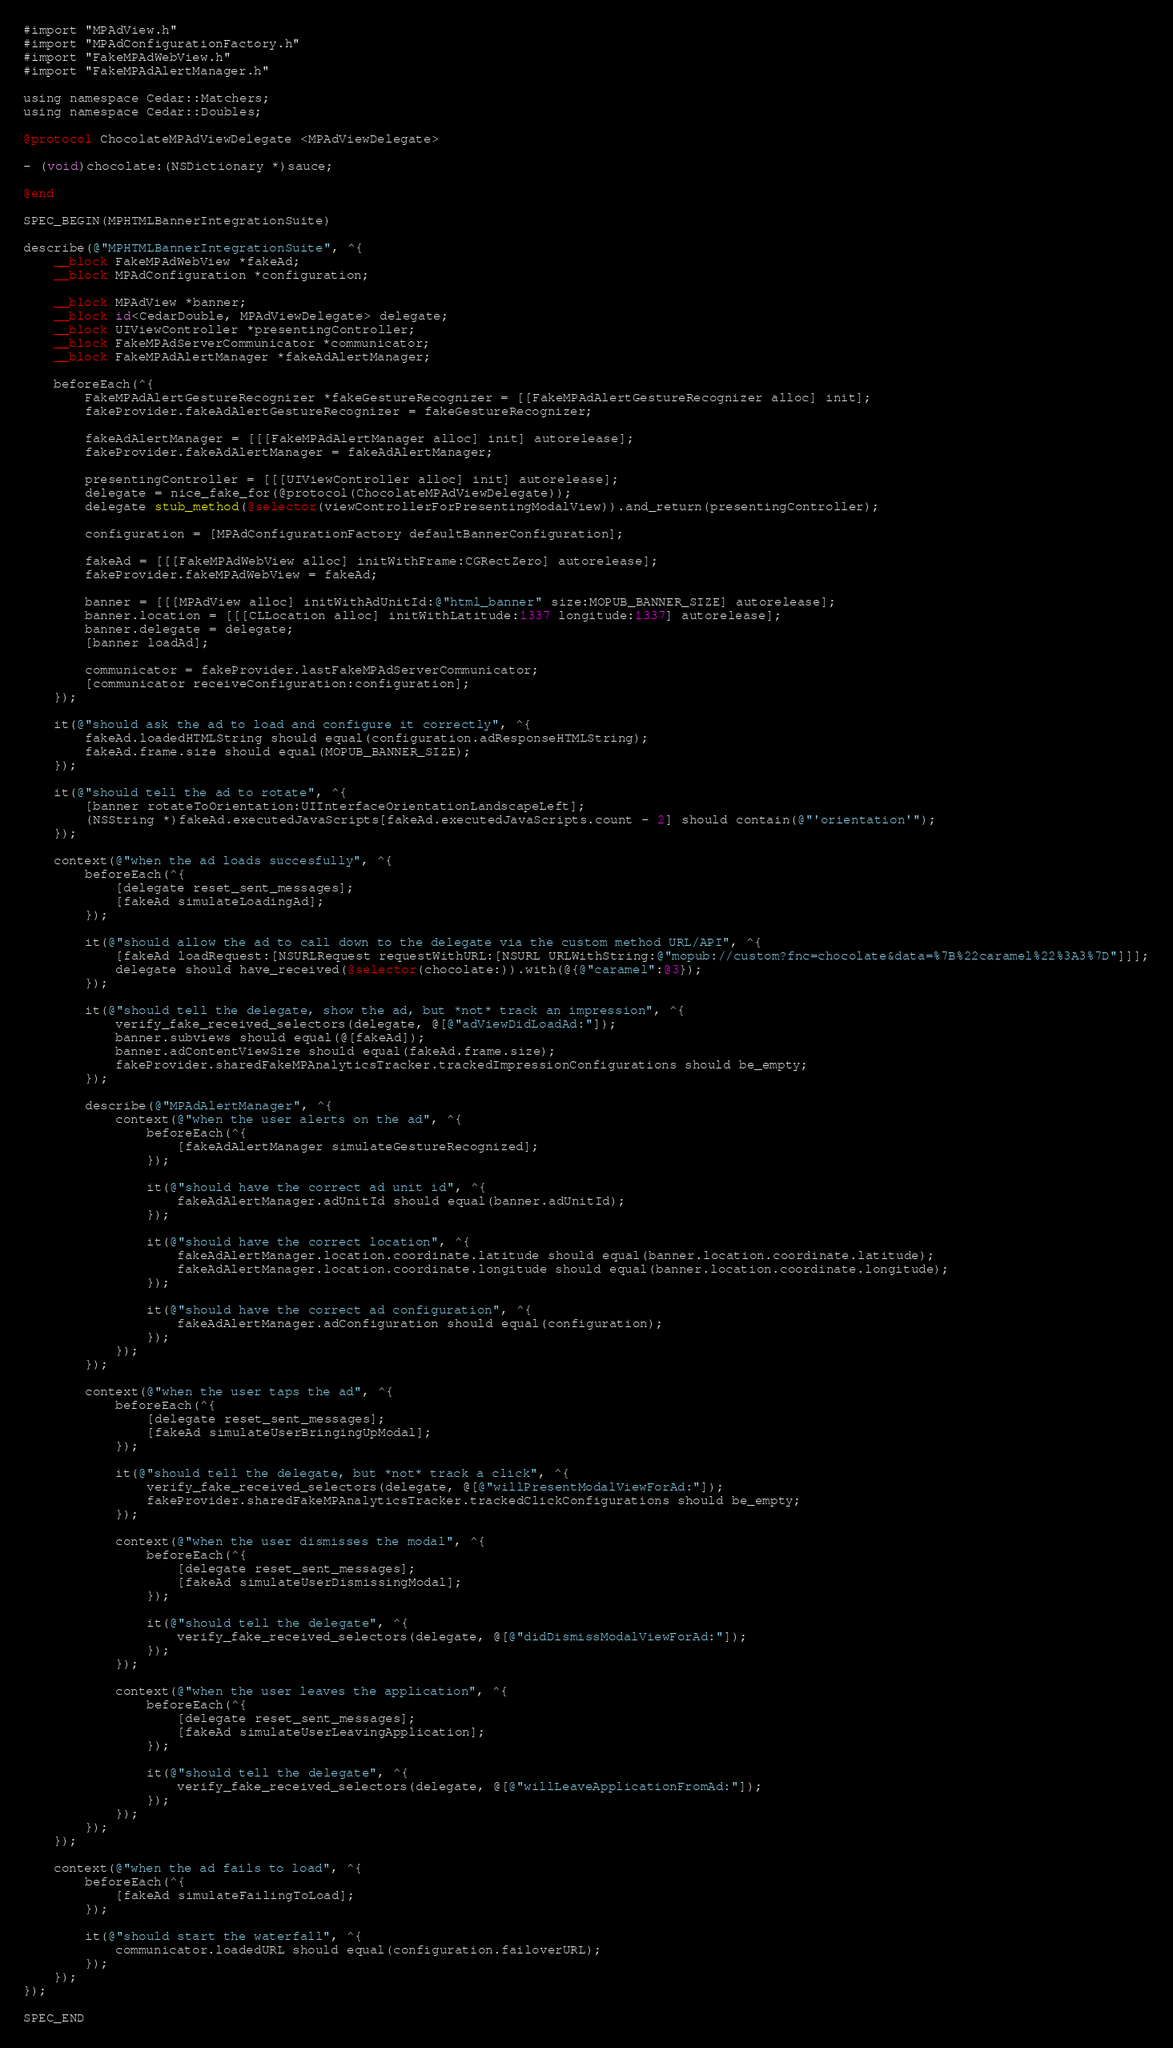<code> <loc_0><loc_0><loc_500><loc_500><_ObjectiveC_>#import "MPAdView.h"
#import "MPAdConfigurationFactory.h"
#import "FakeMPAdWebView.h"
#import "FakeMPAdAlertManager.h"

using namespace Cedar::Matchers;
using namespace Cedar::Doubles;

@protocol ChocolateMPAdViewDelegate <MPAdViewDelegate>

- (void)chocolate:(NSDictionary *)sauce;

@end

SPEC_BEGIN(MPHTMLBannerIntegrationSuite)

describe(@"MPHTMLBannerIntegrationSuite", ^{
    __block FakeMPAdWebView *fakeAd;
    __block MPAdConfiguration *configuration;

    __block MPAdView *banner;
    __block id<CedarDouble, MPAdViewDelegate> delegate;
    __block UIViewController *presentingController;
    __block FakeMPAdServerCommunicator *communicator;
    __block FakeMPAdAlertManager *fakeAdAlertManager;

    beforeEach(^{
        FakeMPAdAlertGestureRecognizer *fakeGestureRecognizer = [[FakeMPAdAlertGestureRecognizer alloc] init];
        fakeProvider.fakeAdAlertGestureRecognizer = fakeGestureRecognizer;

        fakeAdAlertManager = [[[FakeMPAdAlertManager alloc] init] autorelease];
        fakeProvider.fakeAdAlertManager = fakeAdAlertManager;

        presentingController = [[[UIViewController alloc] init] autorelease];
        delegate = nice_fake_for(@protocol(ChocolateMPAdViewDelegate));
        delegate stub_method(@selector(viewControllerForPresentingModalView)).and_return(presentingController);

        configuration = [MPAdConfigurationFactory defaultBannerConfiguration];

        fakeAd = [[[FakeMPAdWebView alloc] initWithFrame:CGRectZero] autorelease];
        fakeProvider.fakeMPAdWebView = fakeAd;

        banner = [[[MPAdView alloc] initWithAdUnitId:@"html_banner" size:MOPUB_BANNER_SIZE] autorelease];
        banner.location = [[[CLLocation alloc] initWithLatitude:1337 longitude:1337] autorelease];
        banner.delegate = delegate;
        [banner loadAd];

        communicator = fakeProvider.lastFakeMPAdServerCommunicator;
        [communicator receiveConfiguration:configuration];
    });

    it(@"should ask the ad to load and configure it correctly", ^{
        fakeAd.loadedHTMLString should equal(configuration.adResponseHTMLString);
        fakeAd.frame.size should equal(MOPUB_BANNER_SIZE);
    });

    it(@"should tell the ad to rotate", ^{
        [banner rotateToOrientation:UIInterfaceOrientationLandscapeLeft];
        (NSString *)fakeAd.executedJavaScripts[fakeAd.executedJavaScripts.count - 2] should contain(@"'orientation'");
    });

    context(@"when the ad loads succesfully", ^{
        beforeEach(^{
            [delegate reset_sent_messages];
            [fakeAd simulateLoadingAd];
        });

        it(@"should allow the ad to call down to the delegate via the custom method URL/API", ^{
            [fakeAd loadRequest:[NSURLRequest requestWithURL:[NSURL URLWithString:@"mopub://custom?fnc=chocolate&data=%7B%22caramel%22%3A3%7D"]]];
            delegate should have_received(@selector(chocolate:)).with(@{@"caramel":@3});
        });

        it(@"should tell the delegate, show the ad, but *not* track an impression", ^{
            verify_fake_received_selectors(delegate, @[@"adViewDidLoadAd:"]);
            banner.subviews should equal(@[fakeAd]);
            banner.adContentViewSize should equal(fakeAd.frame.size);
            fakeProvider.sharedFakeMPAnalyticsTracker.trackedImpressionConfigurations should be_empty;
        });

        describe(@"MPAdAlertManager", ^{
            context(@"when the user alerts on the ad", ^{
                beforeEach(^{
                    [fakeAdAlertManager simulateGestureRecognized];
                });

                it(@"should have the correct ad unit id", ^{
                    fakeAdAlertManager.adUnitId should equal(banner.adUnitId);
                });

                it(@"should have the correct location", ^{
                    fakeAdAlertManager.location.coordinate.latitude should equal(banner.location.coordinate.latitude);
                    fakeAdAlertManager.location.coordinate.longitude should equal(banner.location.coordinate.longitude);
                });

                it(@"should have the correct ad configuration", ^{
                    fakeAdAlertManager.adConfiguration should equal(configuration);
                });
            });
        });

        context(@"when the user taps the ad", ^{
            beforeEach(^{
                [delegate reset_sent_messages];
                [fakeAd simulateUserBringingUpModal];
            });

            it(@"should tell the delegate, but *not* track a click", ^{
                verify_fake_received_selectors(delegate, @[@"willPresentModalViewForAd:"]);
                fakeProvider.sharedFakeMPAnalyticsTracker.trackedClickConfigurations should be_empty;
            });

            context(@"when the user dismisses the modal", ^{
                beforeEach(^{
                    [delegate reset_sent_messages];
                    [fakeAd simulateUserDismissingModal];
                });

                it(@"should tell the delegate", ^{
                    verify_fake_received_selectors(delegate, @[@"didDismissModalViewForAd:"]);
                });
            });

            context(@"when the user leaves the application", ^{
                beforeEach(^{
                    [delegate reset_sent_messages];
                    [fakeAd simulateUserLeavingApplication];
                });

                it(@"should tell the delegate", ^{
                    verify_fake_received_selectors(delegate, @[@"willLeaveApplicationFromAd:"]);
                });
            });
        });
    });

    context(@"when the ad fails to load", ^{
        beforeEach(^{
            [fakeAd simulateFailingToLoad];
        });

        it(@"should start the waterfall", ^{
            communicator.loadedURL should equal(configuration.failoverURL);
        });
    });
});

SPEC_END
</code> 